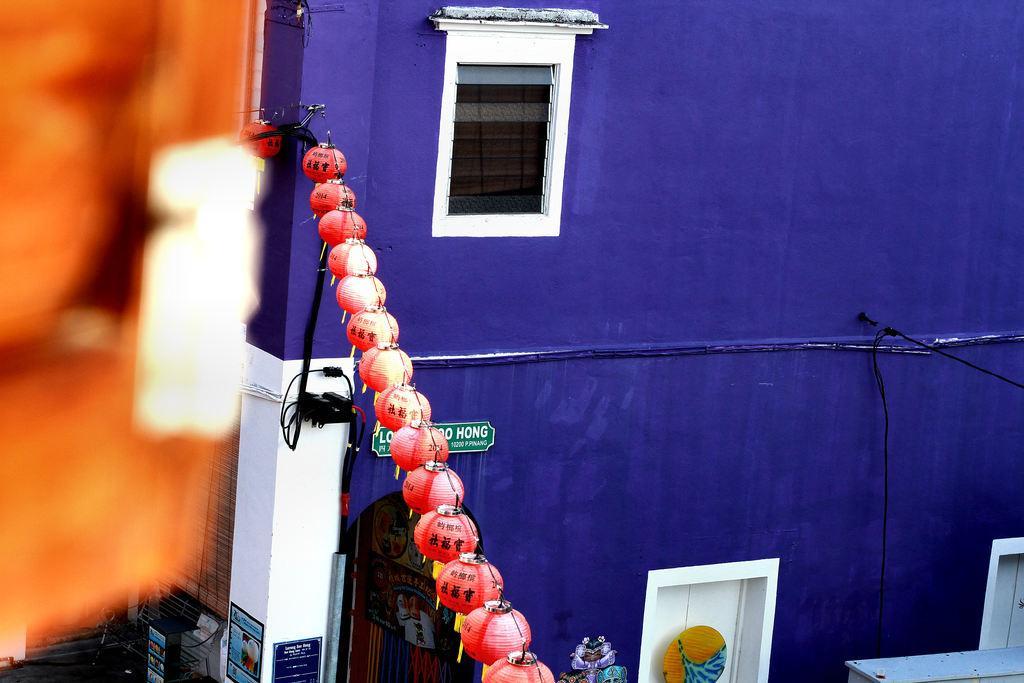In one or two sentences, can you explain what this image depicts? In this picture I can see there are lights arranged in a straight line and there is a blue color building with a window. 